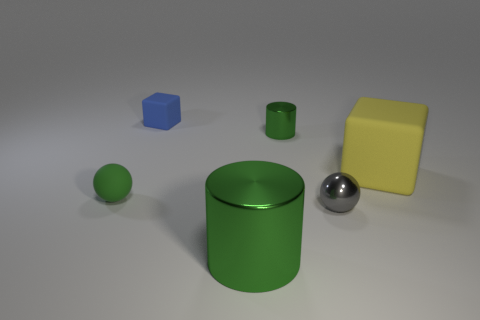What materials appear to make up the objects in this scene? The objects in the scene appear to be made of various materials. The small blue cube and the yellow square look like matte plastic, the green objects seem to have a shiny metallic finish, and the sphere appears to have a reflective surface similar to polished metal or chrome. 